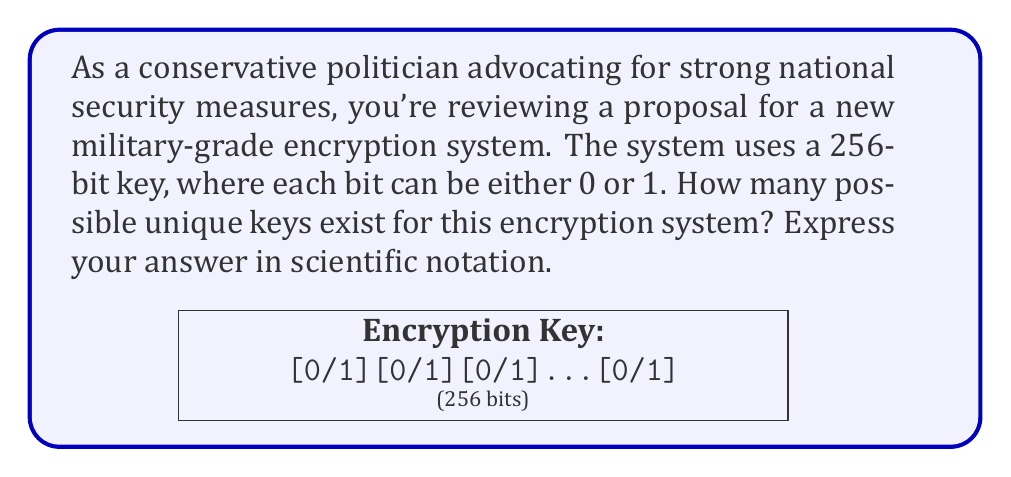Provide a solution to this math problem. Let's approach this step-by-step:

1) In a binary system (where each digit can be either 0 or 1), the number of possibilities for each position is 2.

2) We have 256 positions in our key, and each position can be filled in 2 ways.

3) This is a perfect scenario for using the multiplication principle of combinatorics. When we have a sequence of independent choices, we multiply the number of possibilities for each choice.

4) Therefore, the total number of possible keys is:

   $$2 \times 2 \times 2 \times ... \times 2$$ (256 times)

5) This can be written as an exponent:

   $$2^{256}$$

6) To calculate this:
   
   $$2^{256} = 115,792,089,237,316,195,423,570,985,008,687,907,853,269,984,665,640,564,039,457,584,007,913,129,639,936$$

7) In scientific notation, this is approximately:

   $$1.1579 \times 10^{77}$$

This incredibly large number demonstrates the strength of a 256-bit key, making it extremely difficult for potential adversaries to break through brute-force methods, thus ensuring robust national security.
Answer: $1.1579 \times 10^{77}$ 